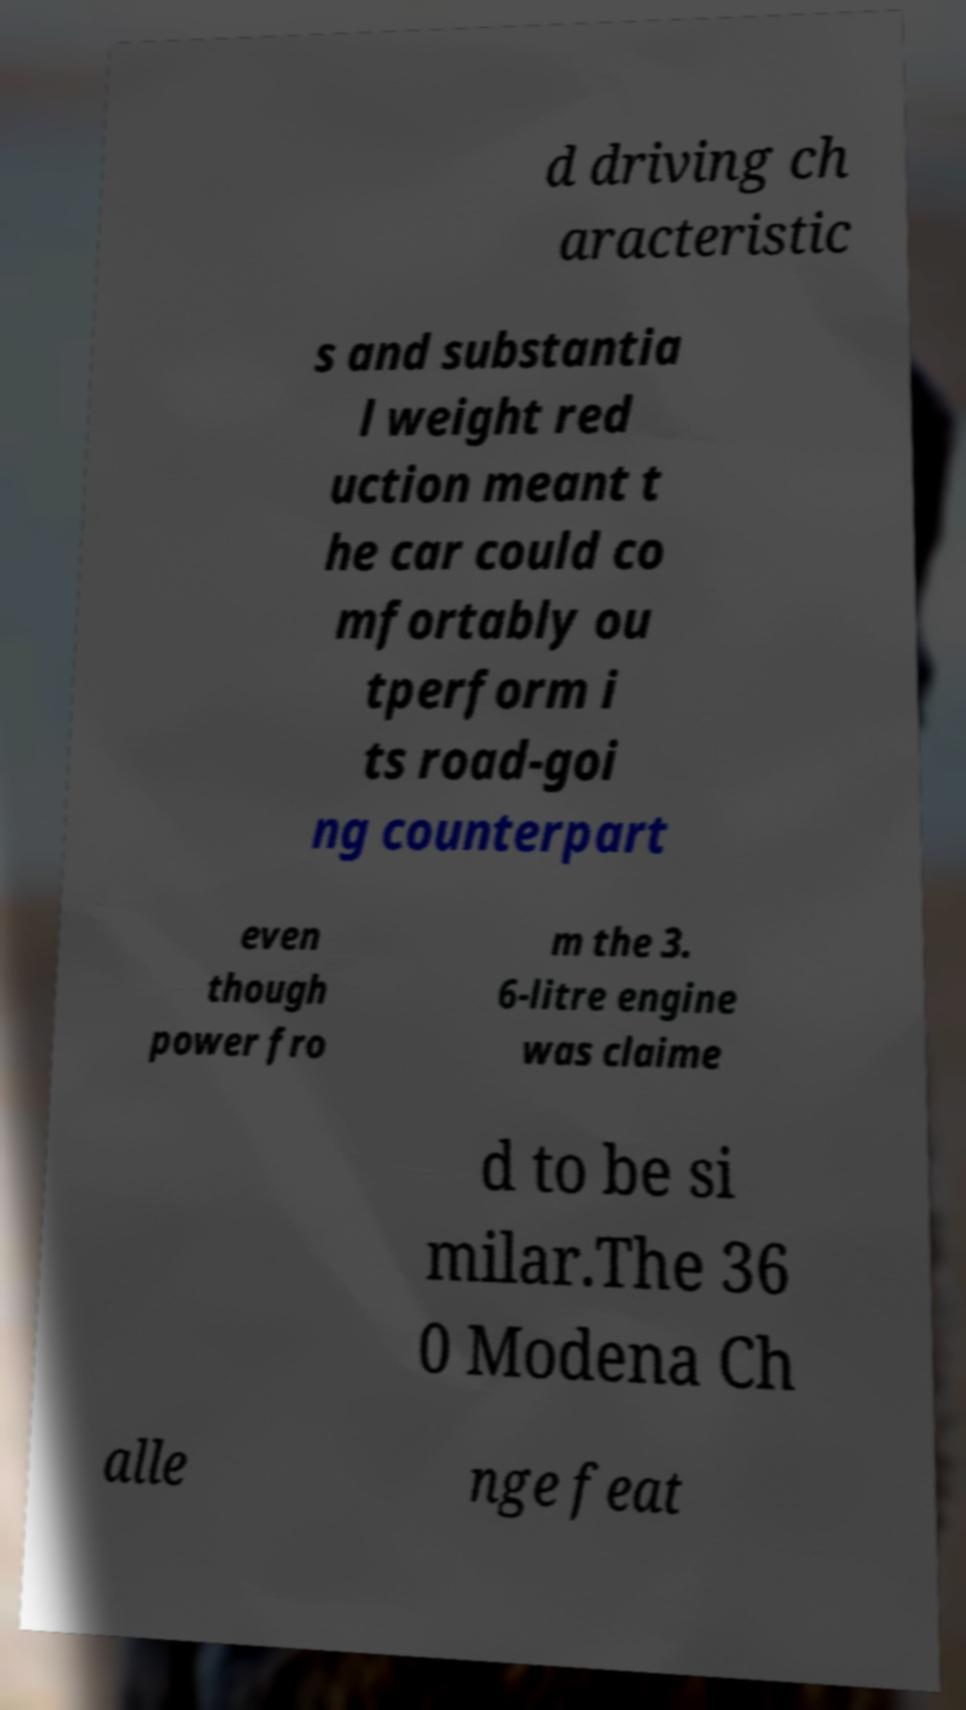Could you extract and type out the text from this image? d driving ch aracteristic s and substantia l weight red uction meant t he car could co mfortably ou tperform i ts road-goi ng counterpart even though power fro m the 3. 6-litre engine was claime d to be si milar.The 36 0 Modena Ch alle nge feat 